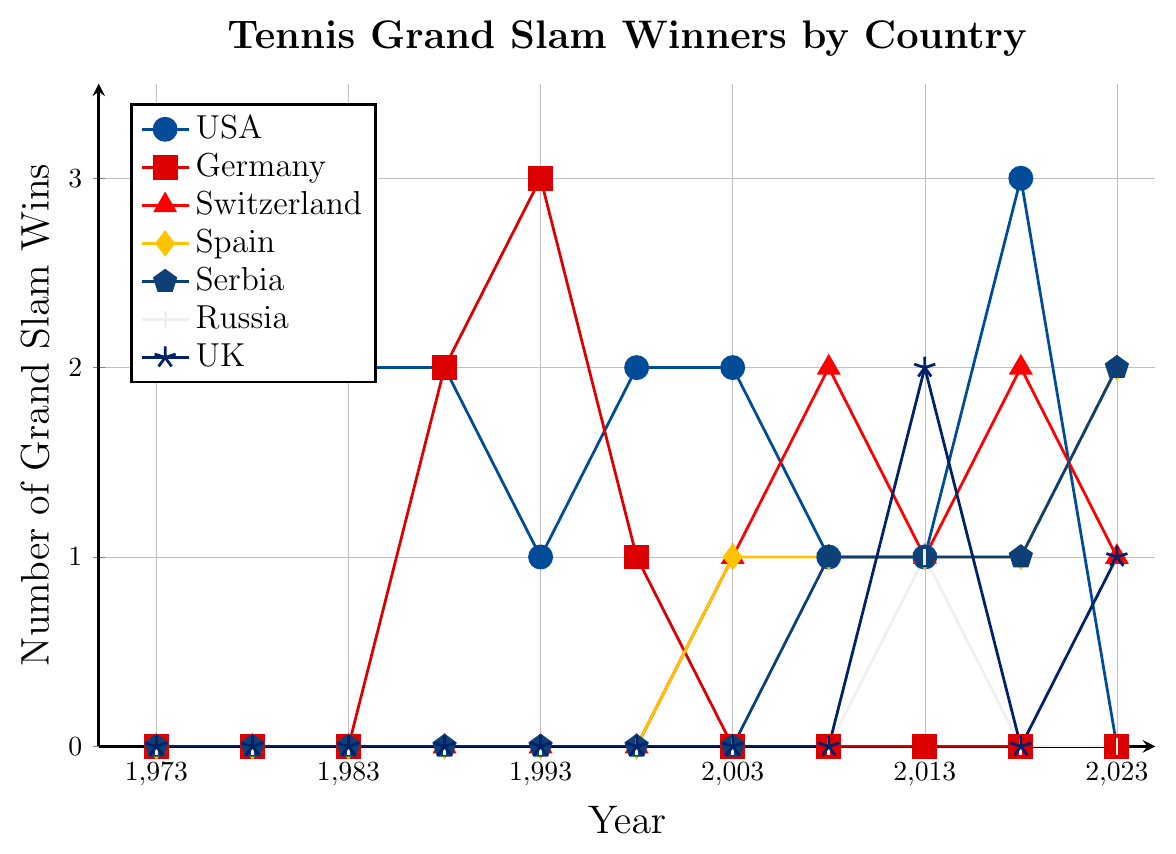What trend is observed for the USA from 1973 to 2023? The line for the USA generally decreases over time, starting high in 1973 with 3 wins, dipping to 0 wins by 2023, but with a slight peak of 3 wins again in 2018.
Answer: Decreasing trend How many Grand Slam wins did Germany have in 1993? Observe the line for Germany in the year 1993. The line reaches up to 3 wins.
Answer: 3 Which country had the highest number of Grand Slam wins in 2008? Compare the height of all the lines in 2008. Switzerland had the highest value with 2 wins.
Answer: Switzerland Compare the number of Grand Slam wins between Spain and Serbia in 2023. In 2023, the line for Spain reaches 2 wins, while the line for Serbia also reaches 2 wins. Thus, they are equal.
Answer: Equal Which country had a decrease in the number of Grand Slam wins between 2018 and 2023? Check the values for each country in 2018 and compare them to 2023. The USA decreased from 3 to 0 wins.
Answer: USA How many more Grand Slam wins did the UK have than Russia in 2013? In 2013, the UK had 2 wins and Russia had 1 win, so UK had 2 - 1 = 1 more win than Russia.
Answer: 1 In which years did Switzerland win exactly 2 Grand Slams? Look for the years where the line for Switzerland reaches the value of 2. This occurs in 2008 and 2018.
Answer: 2008, 2018 What was the average number of Grand Slam wins for Germany from 1973 to 2023? Sum the wins for the years provided (0+0+0+2+3+1+0+0+0+0+0=6), then divide by the number of observations (11). Average = 6/11 ≈ 0.55.
Answer: 0.55 Did any country have consistent Grand Slam wins every recorded year from 1973 to 2023? Verify each country’s series for any that have non-zero values every year. None of the countries had consistent (non-zero) wins every recorded year.
Answer: No Compare the Grand Slam wins between Switzerland and Spain in 2003. In 2003, Switzerland had 1 win and Spain had 1 win. They both had the same number of wins.
Answer: Equal 